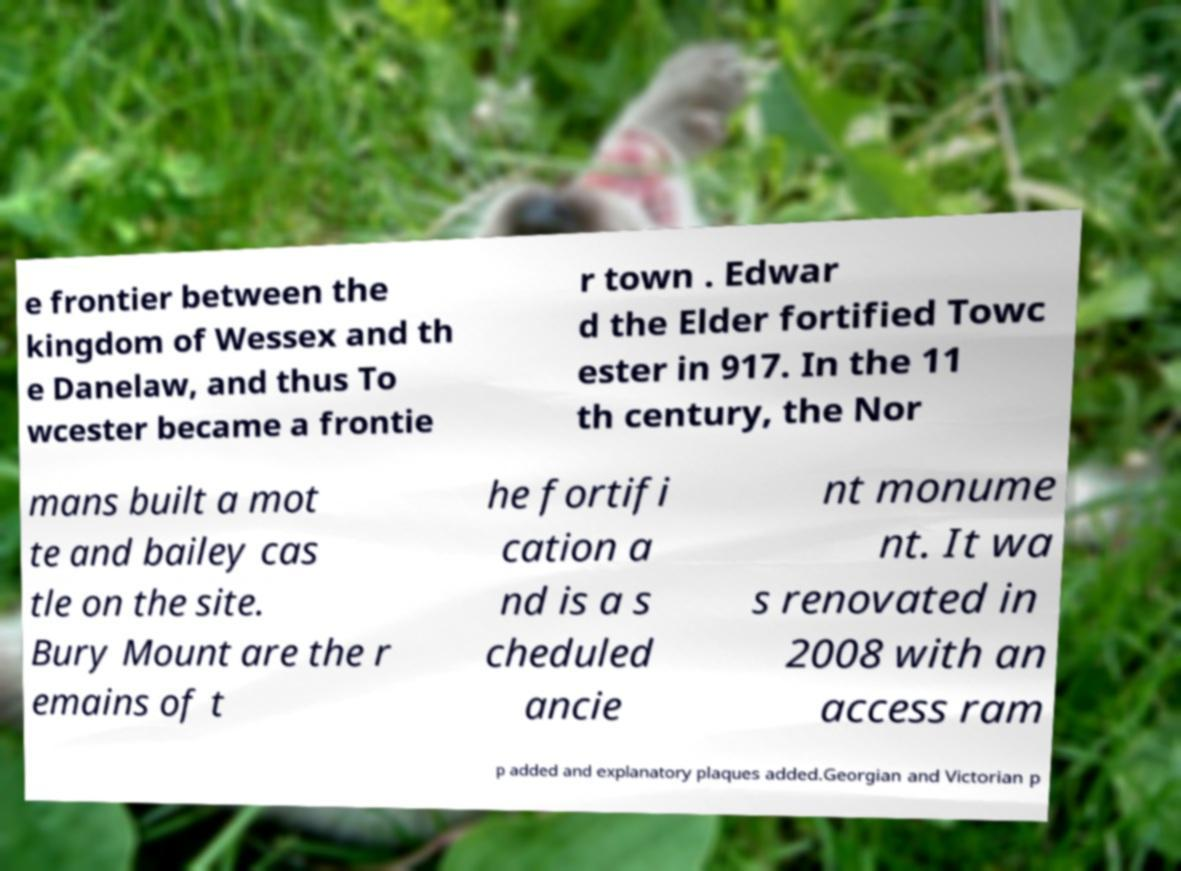Could you extract and type out the text from this image? e frontier between the kingdom of Wessex and th e Danelaw, and thus To wcester became a frontie r town . Edwar d the Elder fortified Towc ester in 917. In the 11 th century, the Nor mans built a mot te and bailey cas tle on the site. Bury Mount are the r emains of t he fortifi cation a nd is a s cheduled ancie nt monume nt. It wa s renovated in 2008 with an access ram p added and explanatory plaques added.Georgian and Victorian p 